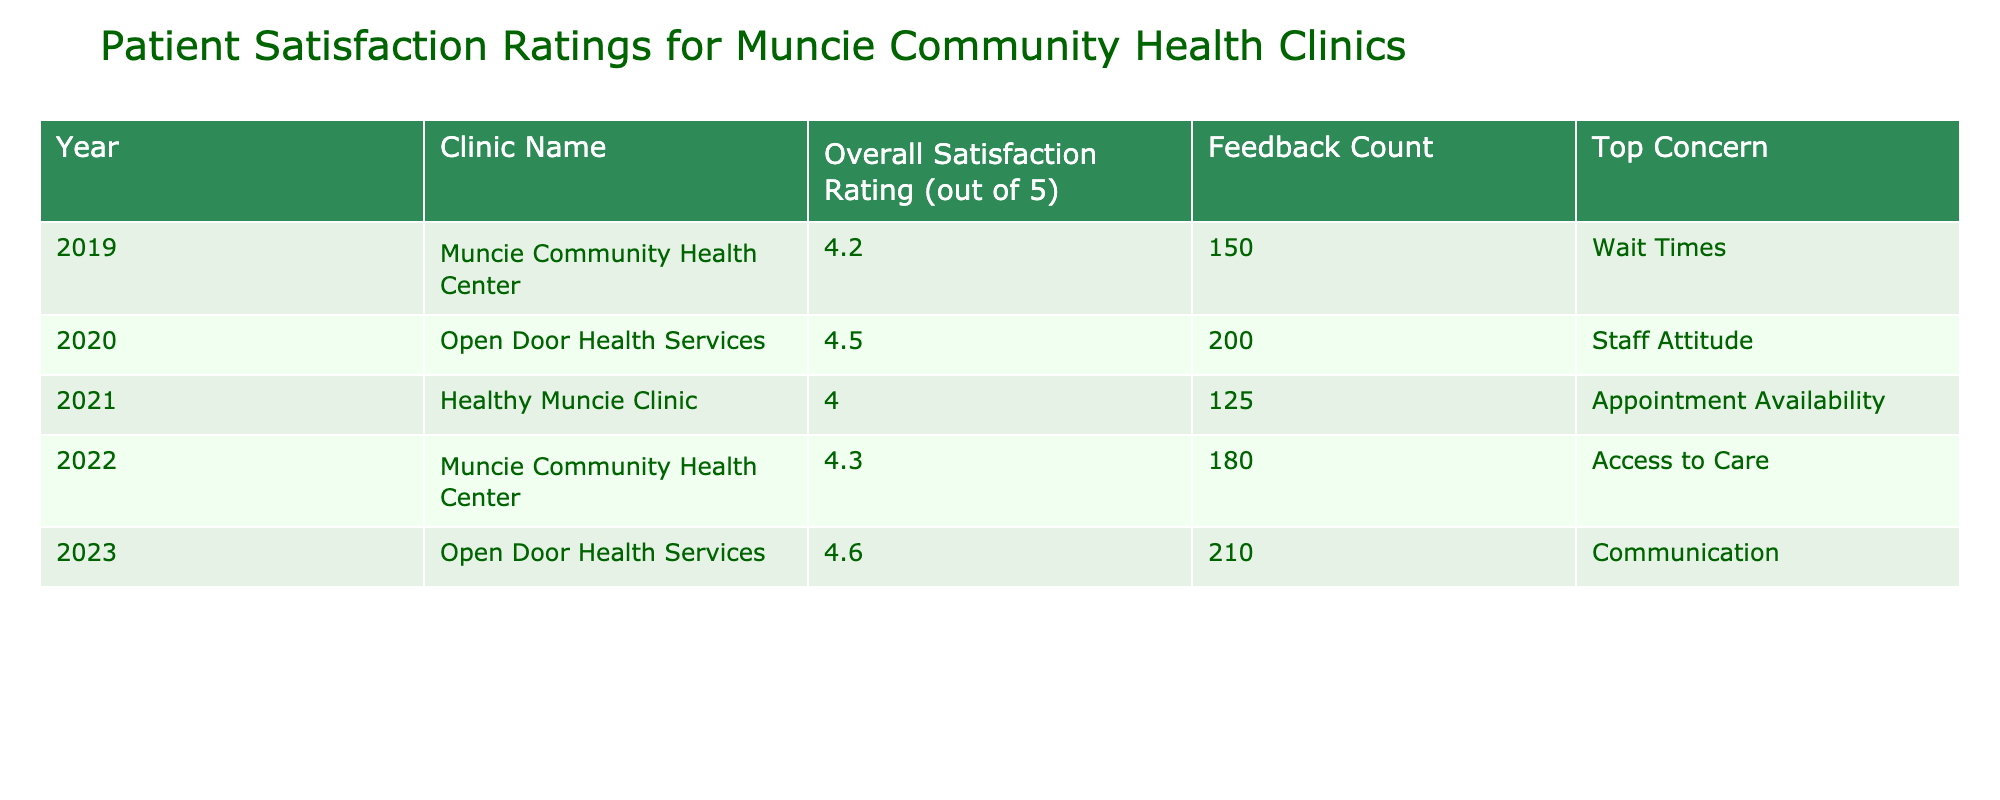What was the overall satisfaction rating for Open Door Health Services in 2023? The table shows that the overall satisfaction rating for Open Door Health Services in 2023 is 4.6.
Answer: 4.6 What is the top concern reported by Healthy Muncie Clinic in 2021? According to the table, the top concern reported by Healthy Muncie Clinic in 2021 is Appointment Availability.
Answer: Appointment Availability Which clinic had the highest overall satisfaction rating over the last five years? The highest overall satisfaction rating recorded in the table is 4.6 for Open Door Health Services in 2023.
Answer: Open Door Health Services How many feedback counts did Muncie Community Health Center receive in 2022? The table indicates that Muncie Community Health Center received 180 feedback counts in 2022.
Answer: 180 What is the average overall satisfaction rating for all clinics across the five years? The satisfaction ratings are 4.2, 4.5, 4.0, 4.3, and 4.6. When summed (4.2 + 4.5 + 4.0 + 4.3 + 4.6 = 21.6) and averaged (21.6 / 5), the average overall satisfaction rating is 4.32.
Answer: 4.32 Was the top concern for Open Door Health Services in 2020 related to wait times? The data from the table shows that the top concern for Open Door Health Services in 2020 was Staff Attitude, not Wait Times. Therefore, the answer is no.
Answer: No In how many years did Muncie Community Health Center receive a satisfaction rating above 4.0? The ratings for Muncie Community Health Center are 4.2 in 2019 and 4.3 in 2022, which are both above 4.0, leading to a total of 2 years.
Answer: 2 years Which clinic had the most total feedback counts across all five years? By adding the feedback counts: 150 + 200 + 125 + 180 + 210 = 865 for Open Door Health Services (200 in 2020 + 210 in 2023), and 150 + 180 = 330 for Muncie Community Health Center, and 125 for Healthy Muncie Clinic. Therefore, Open Door Health Services had the most total feedback counts.
Answer: Open Door Health Services Did the overall satisfaction rating increase from 2021 to 2022 for Healthy Muncie Clinic? The rating for Healthy Muncie Clinic is 4.0 in 2021 and drops to 4.3 in 2022, which indicates an increase from one year to the next. Thus, the answer is yes.
Answer: Yes 